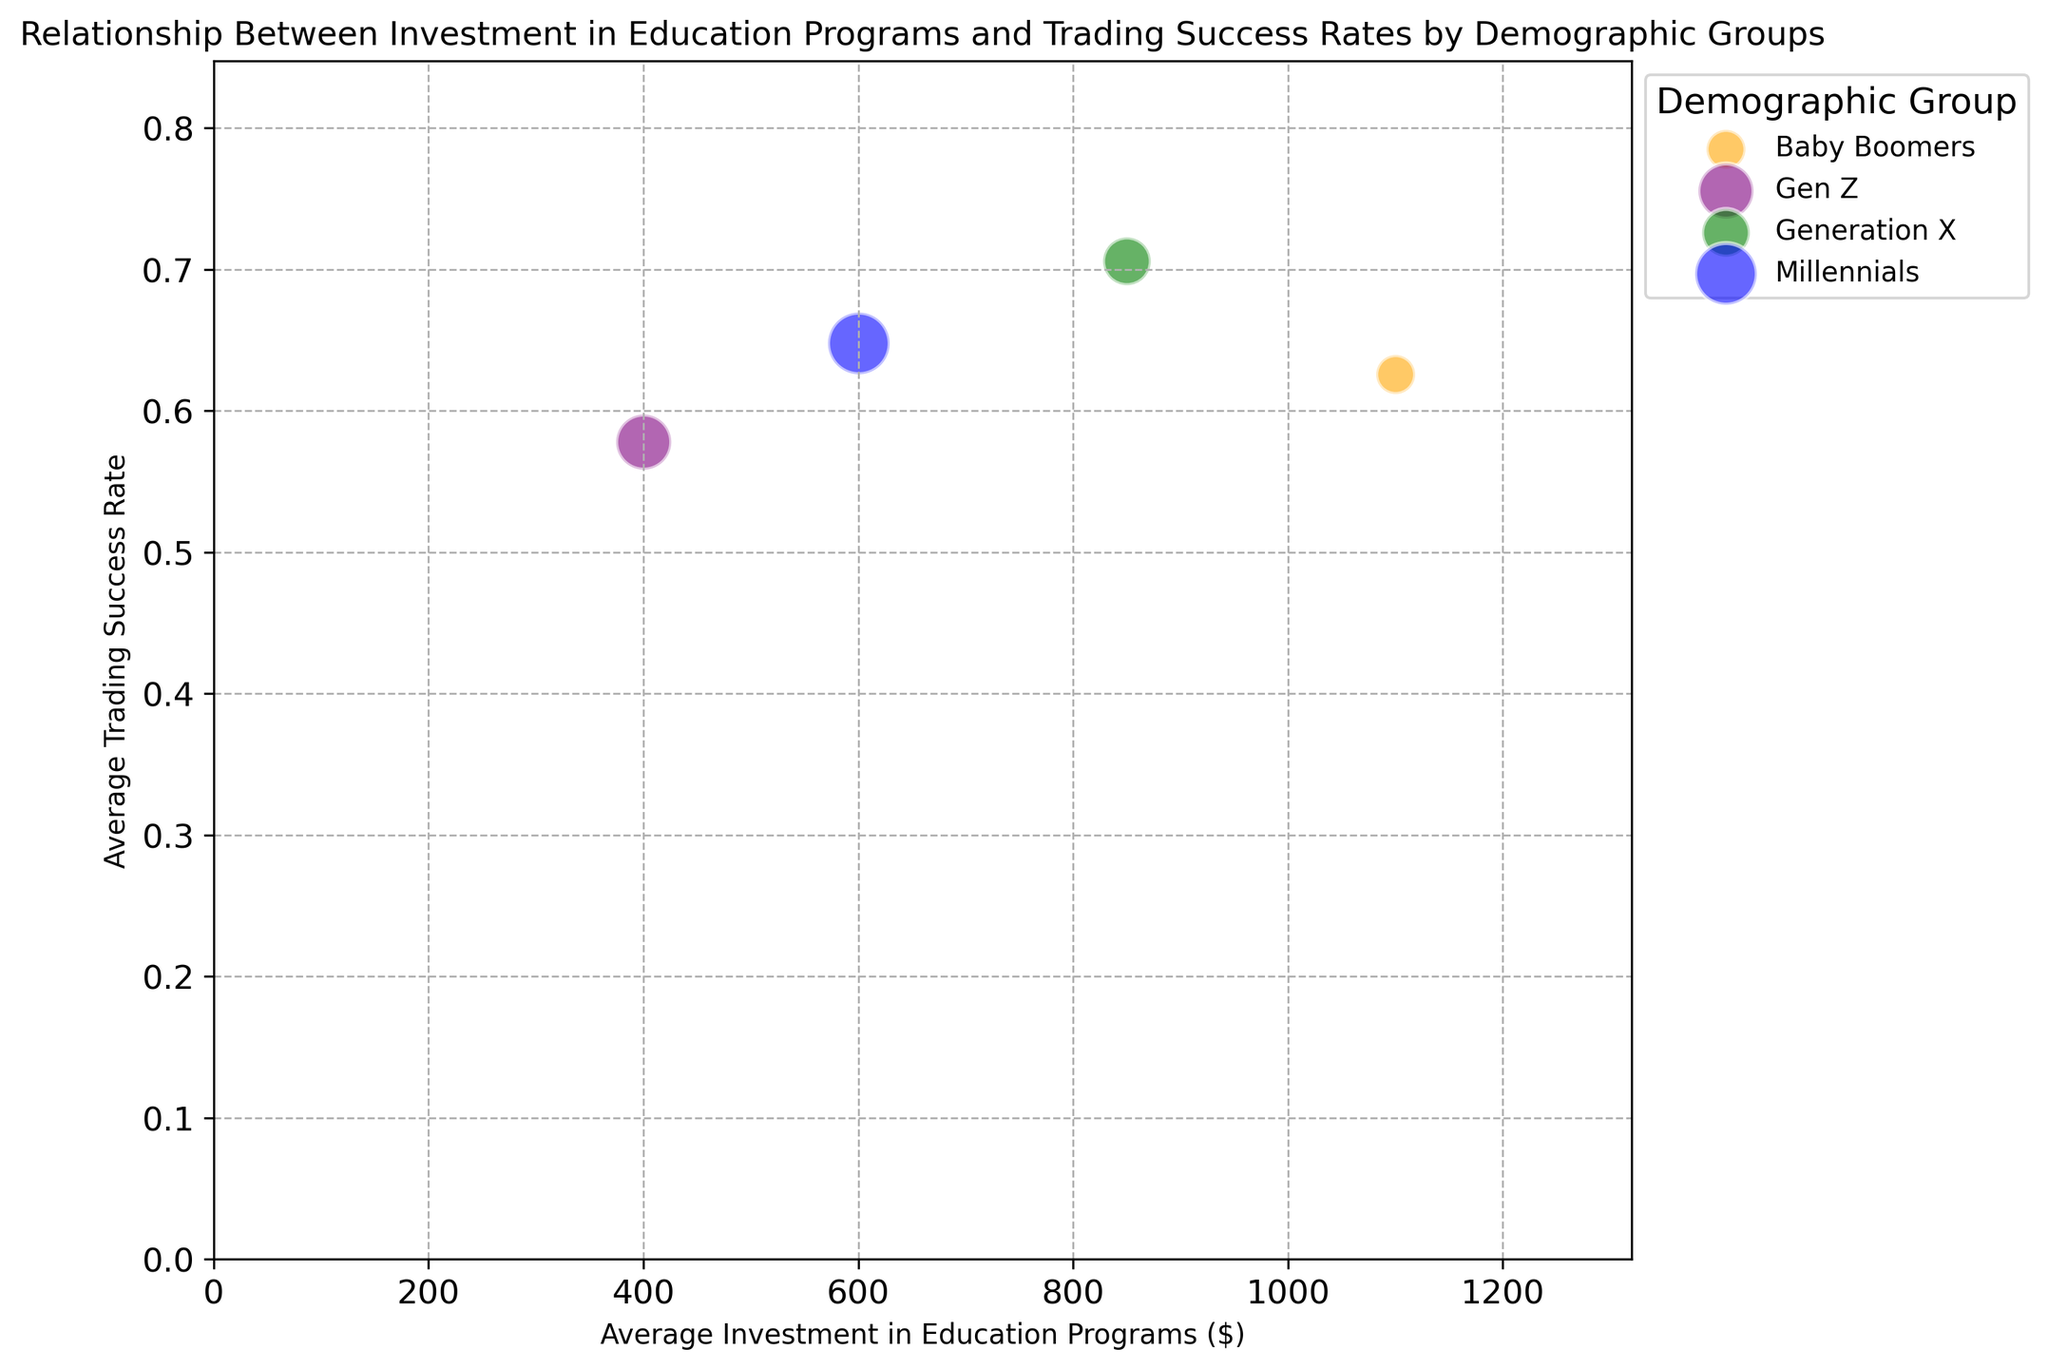What's the average investment in education programs for Generation X? Generation X's average investment in education programs falls along the x-axis. Looking at their position, the average investment is around $850.
Answer: $850 Which demographic group has the highest average trading success rate? The highest average trading success rate is represented by the bubbles that are positioned highest on the y-axis. Generation X bubbles occupy the highest position on the y-axis indicating the highest success rate.
Answer: Generation X Which group has the smallest population size? The size of the bubbles represents the population size. The smallest bubbles belong to the Baby Boomers group.
Answer: Baby Boomers Is there a demographic group that has a high investment but a lower success rate compared to another group with a lower investment? Comparing the positions, Baby Boomers have a high investment (around $1000-$1200) but a lower success rate (~0.60-0.65) compared to Generation X, which has a slightly lower investment (~$850-$950) but a higher success rate (~0.70-0.74).
Answer: Yes, Baby Boomers What’s the average trading success rate difference between Millennials and Gen Z? To determine this, look at the y-axis positions of Millennials (~0.65-0.67) and Gen Z (~0.55-0.61). The difference in trading success rates is approximately 0.66 - 0.575 = 0.085
Answer: 0.085 Which demographic group shows the largest bubble, and what does it signify? The largest bubble signifies the population size and belongs to the Millennials group, indicating they have the largest population.
Answer: Millennials Does higher investment in education programs correlate with higher trading success rates for all groups? Observing the trend lines, Generation X shows a clear positive correlation, Millennials and Gen Z show moderate correlations, but Baby Boomers show a lesser correlation, suggesting no consistent correlation across all groups.
Answer: No If you combine the average investments of Millennials and Gen Z, what's the resultant amount? Summing the average investments, Millennials (~$600) and Gen Z (~$375), results in $600 + $375 = $975.
Answer: $975 